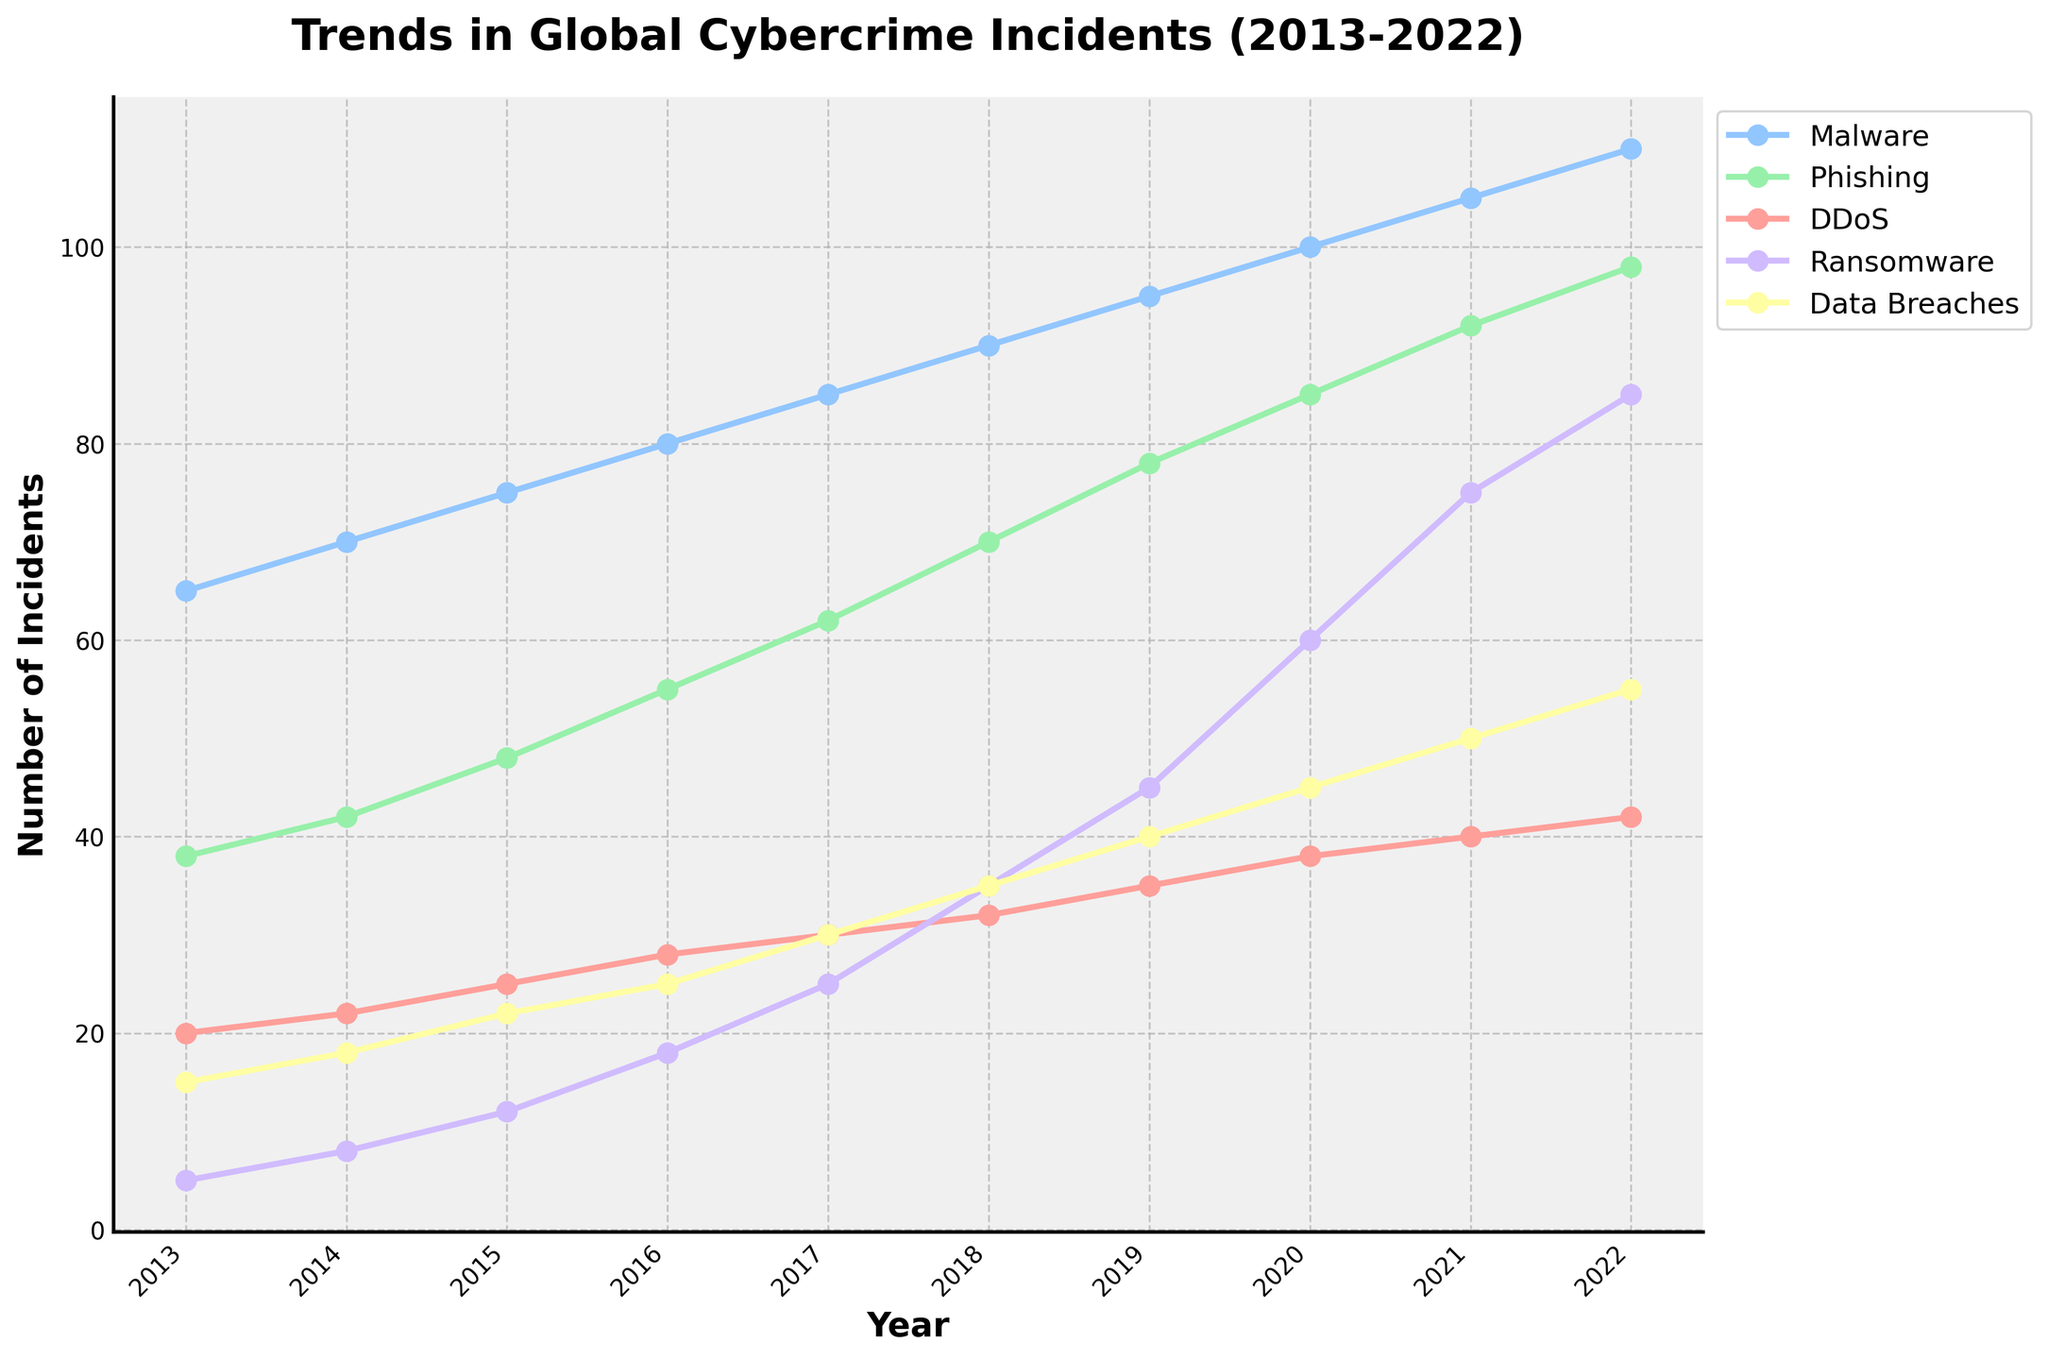What type of cybercrime had the highest number of incidents in 2022? Look at the end of the lines in 2022 on the plot. The line that is highest shows the type of cybercrime with the most incidents. This is the line for Malware.
Answer: Malware How did the number of DDoS incidents change from 2013 to 2022? Identify the values for DDoS in 2013 and 2022 and subtract the 2013 value from the 2022 value. DDoS incidents in 2013 were 20, and in 2022 they were 42, so the change is 42 - 20 = 22.
Answer: Increased by 22 Which cybercrime type had the greatest increase in incidents between 2013 and 2022? Calculate the difference in the number of incidents for each type between 2013 and 2022, then compare these differences. Malware had the highest increase from 65 to 110, which is an increase of 45.
Answer: Malware Which year saw the highest increase in ransomware incidents compared to the previous year? Look at the differences between each year for ransomware on the plot. The biggest jump occurred between 2019 and 2020, where incidents rose from 45 to 60, an increase of 15.
Answer: 2020 In which year did phishing incidents surpass 50 for the first time? Check the trajectory of the phishing line and identify the year where the phishing incidents crossed the 50 marker. This occurred in 2016.
Answer: 2016 What is the average number of data breaches from 2013 to 2022? Sum the number of data breaches across all years and divide by the number of years. The total is \(15+18+22+25+30+35+40+45+50+55 = 335\). The average is \(335/10\).
Answer: 33.5 How many more phishing incidents were there in 2020 compared to ransomware incidents in the same year? Find the number of phishing incidents in 2020 (85) and ransomware incidents in 2020 (60), and subtract the latter from the former: \(85 - 60 = 25\).
Answer: 25 more Which cybercrime type had the least number of incidents in any year, and what was that number? Look for the lowest point on each line. The lowest point on the plot is for ransomware in 2013 with 5 incidents.
Answer: Ransomware, 5 Between which consecutive years did malware incidents show the smallest increase? Calculate the differences for each year and find the smallest difference. The smallest increase for Malware is from 2021 to 2022, where it increased by 5.
Answer: 2021 to 2022 How does the trend of data breaches compare to the trend of malware over the decade? Observe the slope and steepness of the lines for both data breaches and malware. Both lines show upward trends, but the malware line is steeper, indicating a faster increase in incidents.
Answer: Data breaches increased, but slower than malware 